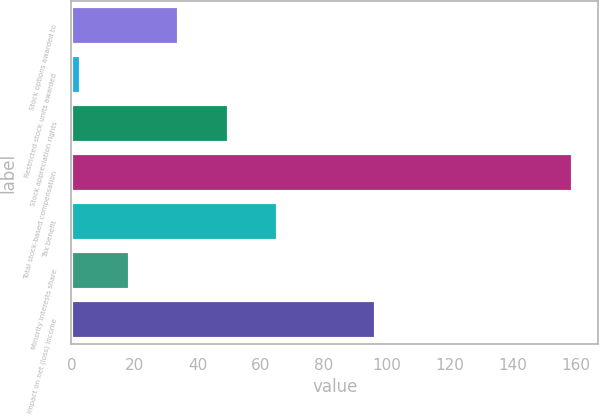<chart> <loc_0><loc_0><loc_500><loc_500><bar_chart><fcel>Stock options awarded to<fcel>Restricted stock units awarded<fcel>Stock appreciation rights<fcel>Total stock-based compensation<fcel>Tax benefit<fcel>Minority interests share<fcel>Impact on net (loss) income<nl><fcel>34.2<fcel>3<fcel>49.8<fcel>159<fcel>65.4<fcel>18.6<fcel>96.6<nl></chart> 